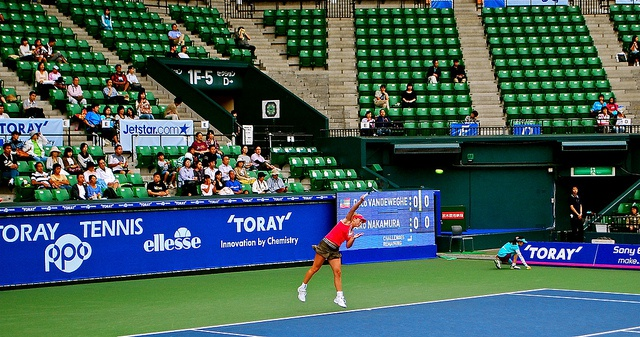Describe the objects in this image and their specific colors. I can see people in black, lightgray, darkgray, and darkgreen tones, people in black, green, red, and lightgray tones, people in black, lavender, maroon, and darkgray tones, people in black, lavender, gray, and darkgray tones, and people in black, maroon, white, and olive tones in this image. 